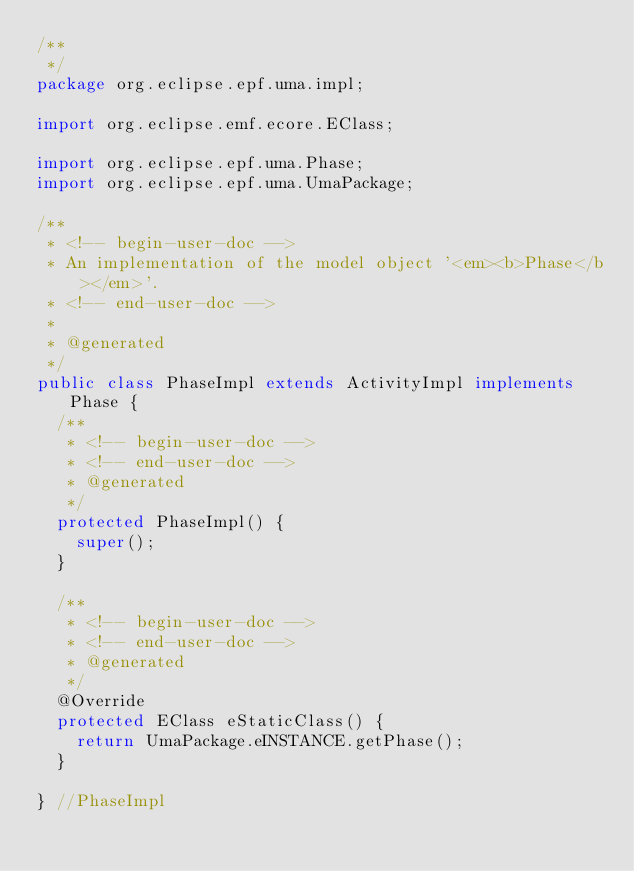<code> <loc_0><loc_0><loc_500><loc_500><_Java_>/**
 */
package org.eclipse.epf.uma.impl;

import org.eclipse.emf.ecore.EClass;

import org.eclipse.epf.uma.Phase;
import org.eclipse.epf.uma.UmaPackage;

/**
 * <!-- begin-user-doc -->
 * An implementation of the model object '<em><b>Phase</b></em>'.
 * <!-- end-user-doc -->
 *
 * @generated
 */
public class PhaseImpl extends ActivityImpl implements Phase {
	/**
	 * <!-- begin-user-doc -->
	 * <!-- end-user-doc -->
	 * @generated
	 */
	protected PhaseImpl() {
		super();
	}

	/**
	 * <!-- begin-user-doc -->
	 * <!-- end-user-doc -->
	 * @generated
	 */
	@Override
	protected EClass eStaticClass() {
		return UmaPackage.eINSTANCE.getPhase();
	}

} //PhaseImpl
</code> 